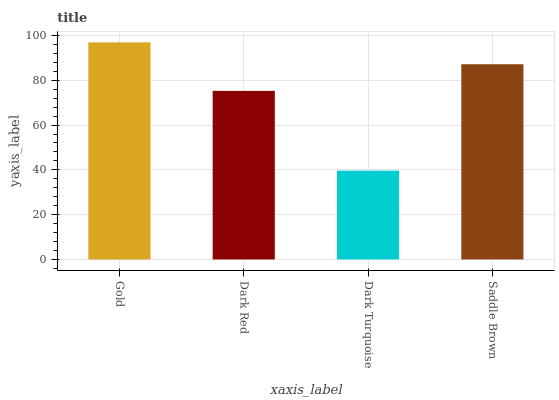Is Dark Turquoise the minimum?
Answer yes or no. Yes. Is Gold the maximum?
Answer yes or no. Yes. Is Dark Red the minimum?
Answer yes or no. No. Is Dark Red the maximum?
Answer yes or no. No. Is Gold greater than Dark Red?
Answer yes or no. Yes. Is Dark Red less than Gold?
Answer yes or no. Yes. Is Dark Red greater than Gold?
Answer yes or no. No. Is Gold less than Dark Red?
Answer yes or no. No. Is Saddle Brown the high median?
Answer yes or no. Yes. Is Dark Red the low median?
Answer yes or no. Yes. Is Dark Turquoise the high median?
Answer yes or no. No. Is Dark Turquoise the low median?
Answer yes or no. No. 